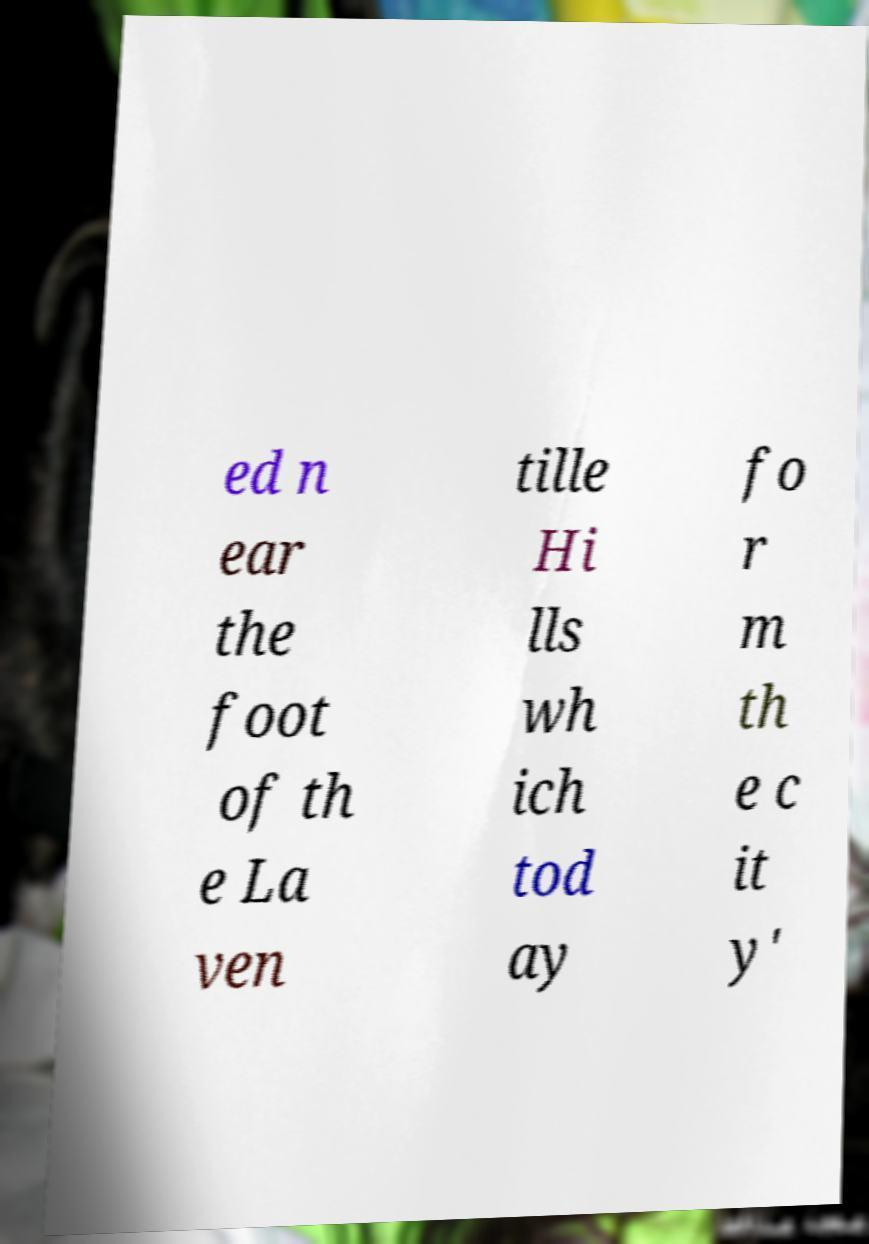Can you read and provide the text displayed in the image?This photo seems to have some interesting text. Can you extract and type it out for me? ed n ear the foot of th e La ven tille Hi lls wh ich tod ay fo r m th e c it y' 